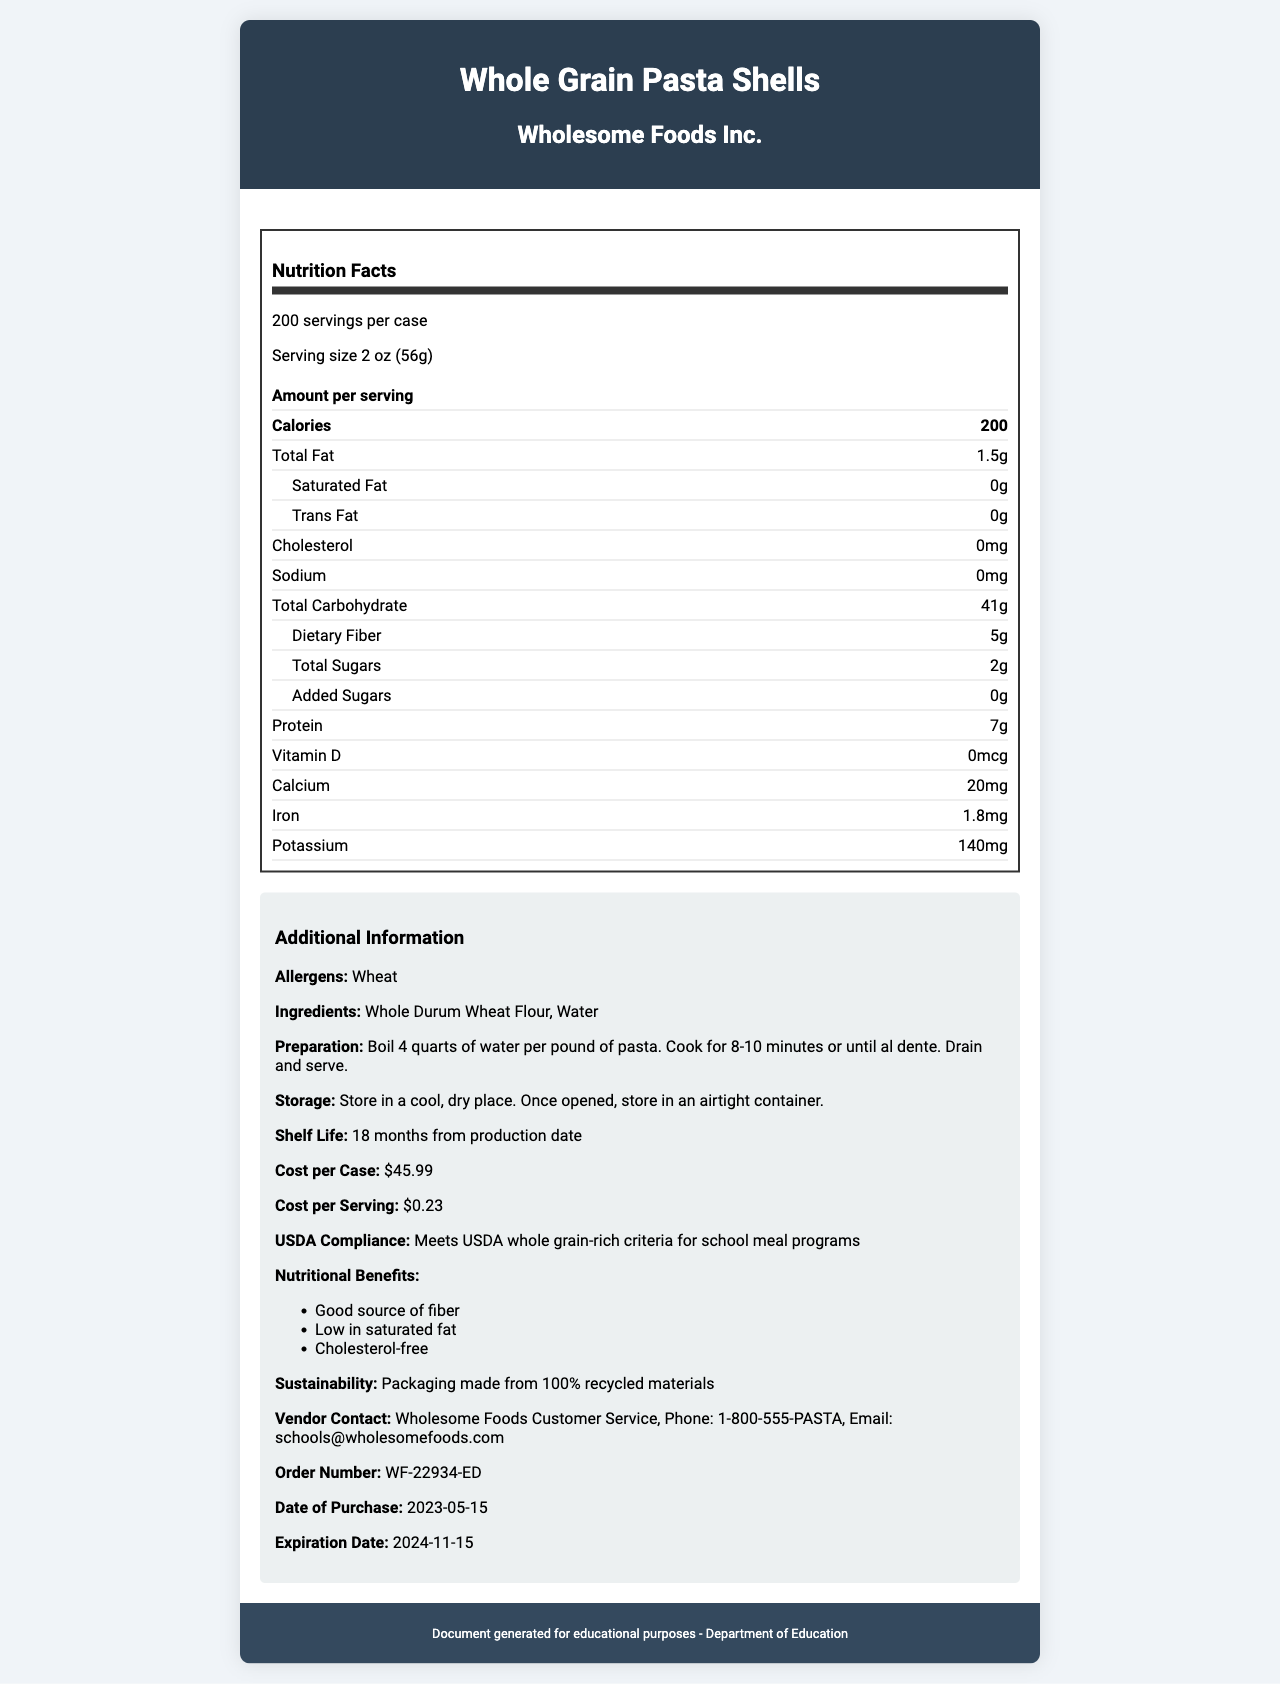what is the serving size? The serving size is explicitly mentioned under "Serving size" in the document.
Answer: 2 oz (56g) how many servings are there in a case? The number of servings per case is stated as "200 servings per case".
Answer: 200 servings who is the manufacturer of the product? The manufacturer's name is provided under the product name at the top of the document.
Answer: Wholesome Foods Inc. what is the shelf life of the product? The shelf life is mentioned under "Shelf Life" in the additional information section.
Answer: 18 months from production date what are the two main ingredients in the pasta? The ingredients list includes "Whole Durum Wheat Flour" and "Water".
Answer: Whole Durum Wheat Flour, Water how many calories are there per serving? A. 150 B. 200 C. 250 D. 100 The number of calories per serving is listed as "Calories: 200".
Answer: B what is the total carbohydrate content per serving? A. 30g B. 40g C. 41g D. 50g The total carbohydrate content is specified as "Total Carbohydrate: 41g".
Answer: C is the product cholesterol-free? The cholesterol content is listed as "0mg," indicating it is cholesterol-free.
Answer: Yes is the product compliant with USDA whole grain-rich criteria? The document explicitly states "Meets USDA whole grain-rich criteria for school meal programs."
Answer: Yes can the vendor's contact phone number be found in the document? The vendor contact section provides the phone number: "1-800-555-PASTA".
Answer: Yes what are the nutritional benefits of the product? The nutritional benefits are listed under "Nutritional Benefits" in the additional information section.
Answer: Good source of fiber, Low in saturated fat, Cholesterol-free what are the allergens present in this product? The allergens are listed under "Allergens" in the additional information section.
Answer: Wheat what is the cost per case of this product? The cost per case is specified as "$45.99" in the additional information section.
Answer: $45.99 what is the total weight of the case? The case weight is mentioned as "25 lbs (11.34 kg)" at the beginning of the document.
Answer: 25 lbs (11.34 kg) summarize the entire document in one sentence. The document primarily addresses the nutritional content, usage, and vendor information of the product, focusing on its utility in school meal programs.
Answer: This document provides the nutritional facts, ingredients, preparation, storage instructions, and vendor contact details for "Whole Grain Pasta Shells" by Wholesome Foods Inc., including its cost, shelf life, and USDA compliance. how long should you boil the pasta? The preparation instructions suggest boiling for "8-10 minutes or until al dente".
Answer: 8-10 minutes or until al dente what is the iron content per serving? The iron content is specified as "Iron: 1.8mg" in the nutritional information.
Answer: 1.8mg what is the cost per serving? The cost per serving is explicitly mentioned as "$0.23" in the document.
Answer: $0.23 does the packaging contain recycled materials? The sustainability info states "Packaging made from 100% recycled materials."
Answer: Yes what is the detailed contact email of the vendor? The vendor contact section provides the email "schools@wholesomefoods.com".
Answer: schools@wholesomefoods.com when does the product expire? The expiration date is given as "2024-11-15" in the document.
Answer: 2024-11-15 what is the calcium content per serving? The calcium content is specified as "Calcium: 20mg" per serving.
Answer: 20mg what is the added sugars content per serving of the pasta? The added sugars content is listed as "0g" in the nutritional information.
Answer: 0g how many quarts of water should you boil per pound of pasta? The preparation instructions suggest boiling "4 quarts of water per pound of pasta."
Answer: 4 quarts is the school authorized to purchase the product based on its shelf life and the purchase date given? The product was purchased on "2023-05-15," and it has an 18-month shelf life, giving a valid use until "2024-11-15".
Answer: Yes how much total weight of pasta is in the entire case of 200 servings? A. 10 lbs B. 50 lbs C. 25 lbs D. 30 lbs The case weight is "25 lbs (11.34 kg)," which is the total weight of the pasta.
Answer: C 